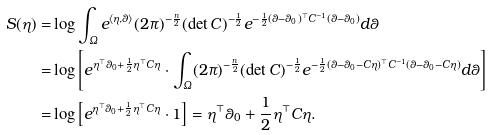Convert formula to latex. <formula><loc_0><loc_0><loc_500><loc_500>S ( \eta ) = & \log \int _ { \varOmega } e ^ { \langle \eta , \theta \rangle } ( 2 \pi ) ^ { - \frac { n } { 2 } } ( \det C ) ^ { - \frac { 1 } { 2 } } e ^ { - \frac { 1 } { 2 } ( \theta - \theta _ { 0 } ) ^ { \top } C ^ { - 1 } ( \theta - \theta _ { 0 } ) } d \theta \\ = & \log \left [ e ^ { \eta ^ { \top } \theta _ { 0 } + \frac { 1 } { 2 } \eta ^ { \top } C \eta } \cdot \int _ { \varOmega } ( 2 \pi ) ^ { - \frac { n } { 2 } } ( \det C ) ^ { - \frac { 1 } { 2 } } e ^ { - \frac { 1 } { 2 } ( \theta - \theta _ { 0 } - C \eta ) ^ { \top } C ^ { - 1 } ( \theta - \theta _ { 0 } - C \eta ) } d \theta \right ] \\ = & \log \left [ e ^ { \eta ^ { \top } \theta _ { 0 } + \frac { 1 } { 2 } \eta ^ { \top } C \eta } \cdot 1 \right ] = \eta ^ { \top } \theta _ { 0 } + \frac { 1 } { 2 } \eta ^ { \top } C \eta .</formula> 